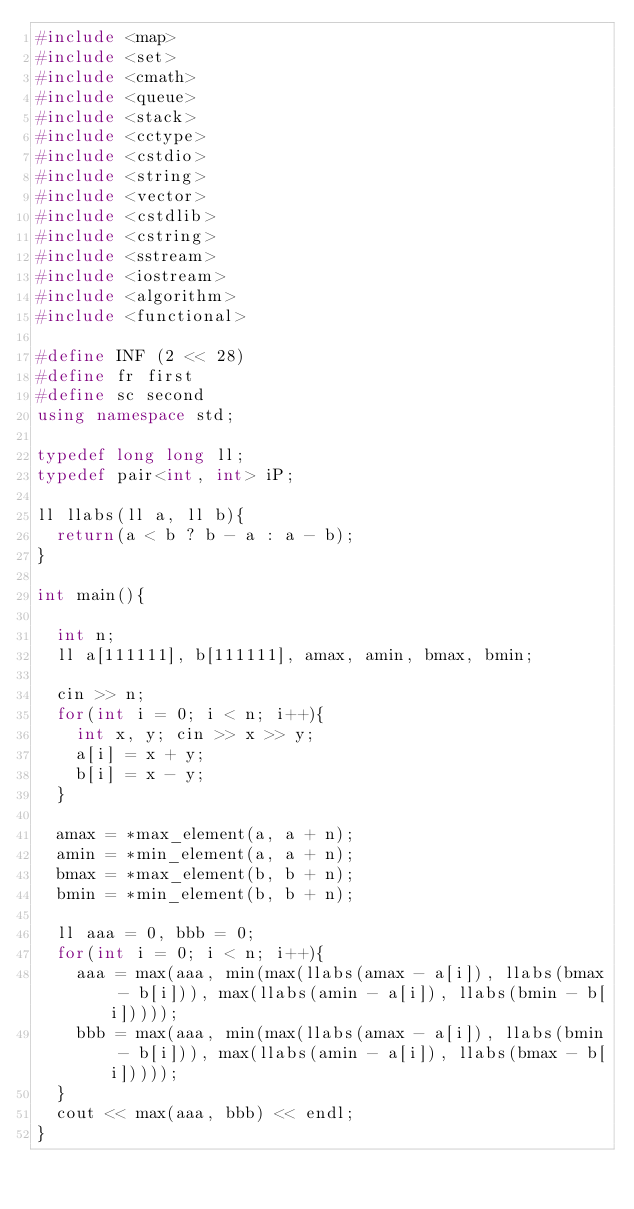Convert code to text. <code><loc_0><loc_0><loc_500><loc_500><_C++_>#include <map>
#include <set>
#include <cmath>
#include <queue>
#include <stack>
#include <cctype>
#include <cstdio>
#include <string>
#include <vector>
#include <cstdlib>
#include <cstring>
#include <sstream>
#include <iostream>
#include <algorithm>
#include <functional>

#define INF (2 << 28)
#define fr first
#define sc second
using namespace std;

typedef long long ll;
typedef pair<int, int> iP;

ll llabs(ll a, ll b){
  return(a < b ? b - a : a - b);
}

int main(){
  
  int n;
  ll a[111111], b[111111], amax, amin, bmax, bmin;
  
  cin >> n;
  for(int i = 0; i < n; i++){
    int x, y; cin >> x >> y;
    a[i] = x + y;
    b[i] = x - y;
  }
  
  amax = *max_element(a, a + n);
  amin = *min_element(a, a + n);
  bmax = *max_element(b, b + n);
  bmin = *min_element(b, b + n);

  ll aaa = 0, bbb = 0;
  for(int i = 0; i < n; i++){
    aaa = max(aaa, min(max(llabs(amax - a[i]), llabs(bmax - b[i])), max(llabs(amin - a[i]), llabs(bmin - b[i]))));
    bbb = max(aaa, min(max(llabs(amax - a[i]), llabs(bmin - b[i])), max(llabs(amin - a[i]), llabs(bmax - b[i]))));
  }
  cout << max(aaa, bbb) << endl;
}</code> 